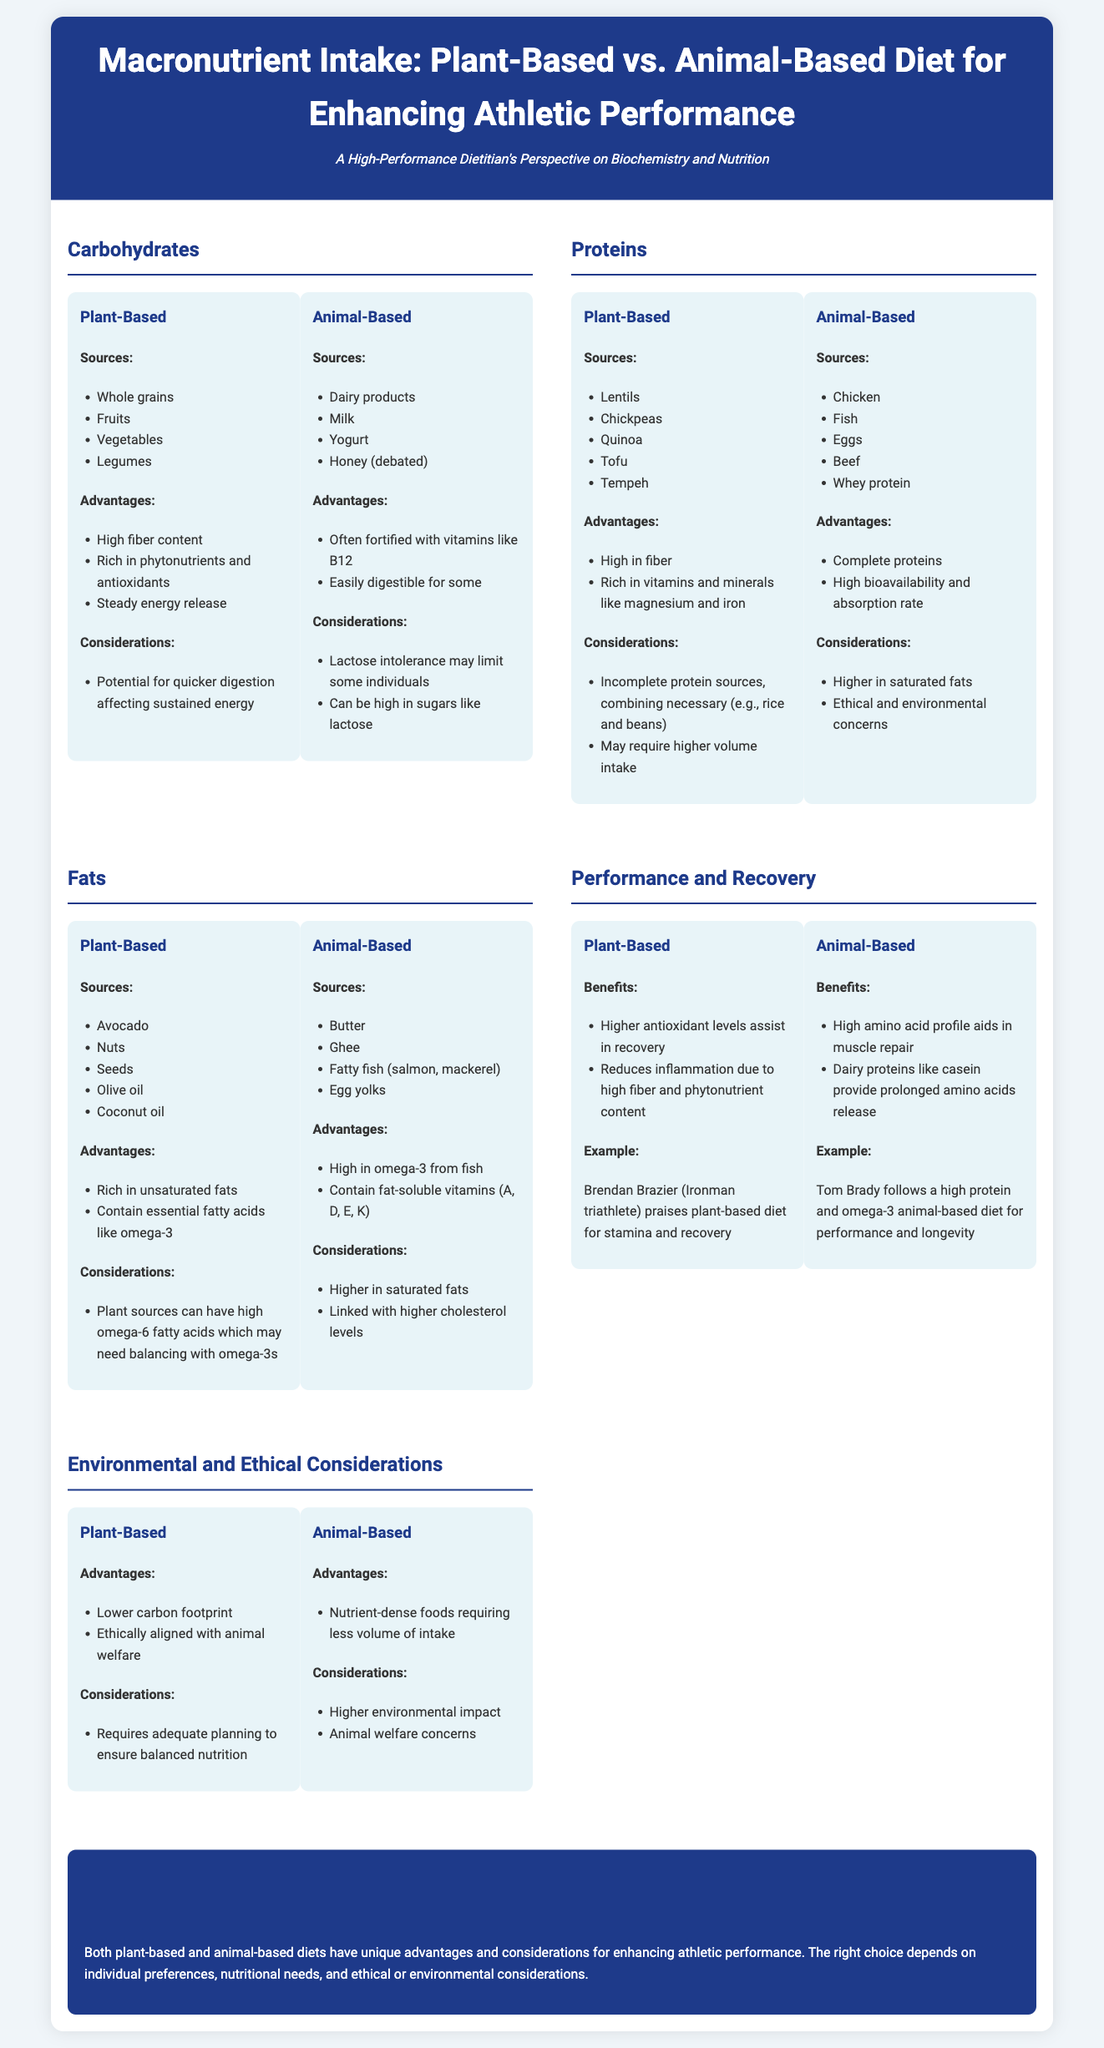What are four sources of carbohydrates in a plant-based diet? The document lists whole grains, fruits, vegetables, and legumes as sources of carbohydrates in a plant-based diet.
Answer: Whole grains, fruits, vegetables, legumes What is a key advantage of plant-based proteins? The document highlights that plant-based proteins are high in fiber and rich in vitamins and minerals like magnesium and iron.
Answer: High in fiber What is the primary benefit of fats from animal-based sources? According to the document, a primary benefit of animal-based fats is that they are high in omega-3 from fish.
Answer: High in omega-3 What example athlete is mentioned in connection with the plant-based diet? The document cites Brendan Brazier, an Ironman triathlete, as an example of someone who praises the plant-based diet for stamina and recovery.
Answer: Brendan Brazier What is a consideration mentioned for animal-based diets? The document discusses that animal-based diets can be higher in saturated fats and pose ethical and environmental concerns.
Answer: Higher in saturated fats What macronutrient is associated with the highest bioavailability in an animal-based diet? The document states that animal-based proteins have high bioavailability and absorption rate.
Answer: High bioavailability What does the conclusion suggest about diet choice? The conclusion indicates that the right choice depends on individual preferences, nutritional needs, and ethical or environmental considerations.
Answer: Individual preferences What essential fatty acid is particularly highlighted in plant-based fats? The document notes that plant-based fats contain essential fatty acids like omega-3.
Answer: Omega-3 